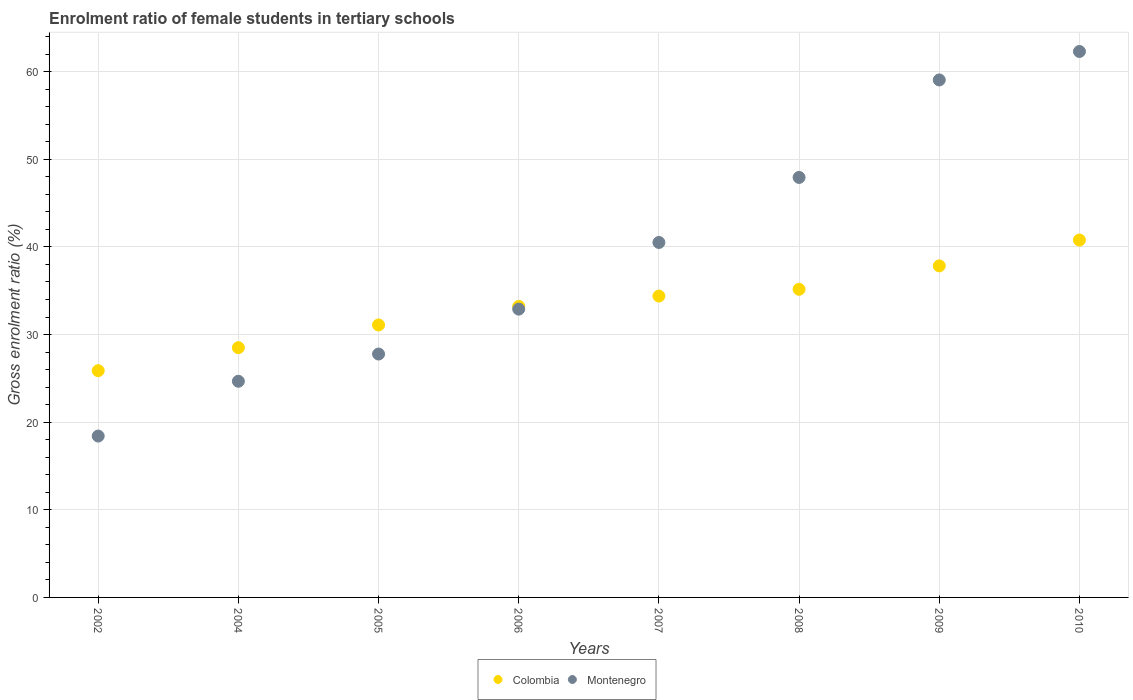How many different coloured dotlines are there?
Provide a short and direct response. 2. What is the enrolment ratio of female students in tertiary schools in Montenegro in 2010?
Offer a terse response. 62.31. Across all years, what is the maximum enrolment ratio of female students in tertiary schools in Colombia?
Keep it short and to the point. 40.79. Across all years, what is the minimum enrolment ratio of female students in tertiary schools in Colombia?
Your response must be concise. 25.88. What is the total enrolment ratio of female students in tertiary schools in Colombia in the graph?
Your answer should be very brief. 266.88. What is the difference between the enrolment ratio of female students in tertiary schools in Montenegro in 2006 and that in 2008?
Make the answer very short. -15.03. What is the difference between the enrolment ratio of female students in tertiary schools in Colombia in 2004 and the enrolment ratio of female students in tertiary schools in Montenegro in 2008?
Give a very brief answer. -19.43. What is the average enrolment ratio of female students in tertiary schools in Colombia per year?
Make the answer very short. 33.36. In the year 2005, what is the difference between the enrolment ratio of female students in tertiary schools in Montenegro and enrolment ratio of female students in tertiary schools in Colombia?
Give a very brief answer. -3.32. In how many years, is the enrolment ratio of female students in tertiary schools in Colombia greater than 32 %?
Offer a very short reply. 5. What is the ratio of the enrolment ratio of female students in tertiary schools in Colombia in 2006 to that in 2007?
Give a very brief answer. 0.97. Is the enrolment ratio of female students in tertiary schools in Montenegro in 2002 less than that in 2007?
Provide a succinct answer. Yes. What is the difference between the highest and the second highest enrolment ratio of female students in tertiary schools in Colombia?
Make the answer very short. 2.95. What is the difference between the highest and the lowest enrolment ratio of female students in tertiary schools in Colombia?
Your answer should be very brief. 14.91. Is the sum of the enrolment ratio of female students in tertiary schools in Montenegro in 2002 and 2005 greater than the maximum enrolment ratio of female students in tertiary schools in Colombia across all years?
Offer a very short reply. Yes. Is the enrolment ratio of female students in tertiary schools in Montenegro strictly greater than the enrolment ratio of female students in tertiary schools in Colombia over the years?
Provide a succinct answer. No. How many years are there in the graph?
Provide a short and direct response. 8. What is the difference between two consecutive major ticks on the Y-axis?
Keep it short and to the point. 10. Does the graph contain any zero values?
Give a very brief answer. No. How many legend labels are there?
Your answer should be compact. 2. How are the legend labels stacked?
Keep it short and to the point. Horizontal. What is the title of the graph?
Keep it short and to the point. Enrolment ratio of female students in tertiary schools. What is the Gross enrolment ratio (%) in Colombia in 2002?
Provide a succinct answer. 25.88. What is the Gross enrolment ratio (%) of Montenegro in 2002?
Make the answer very short. 18.42. What is the Gross enrolment ratio (%) in Colombia in 2004?
Offer a terse response. 28.51. What is the Gross enrolment ratio (%) of Montenegro in 2004?
Offer a very short reply. 24.67. What is the Gross enrolment ratio (%) in Colombia in 2005?
Offer a terse response. 31.1. What is the Gross enrolment ratio (%) in Montenegro in 2005?
Ensure brevity in your answer.  27.78. What is the Gross enrolment ratio (%) of Colombia in 2006?
Give a very brief answer. 33.22. What is the Gross enrolment ratio (%) in Montenegro in 2006?
Offer a terse response. 32.9. What is the Gross enrolment ratio (%) of Colombia in 2007?
Ensure brevity in your answer.  34.39. What is the Gross enrolment ratio (%) in Montenegro in 2007?
Provide a short and direct response. 40.51. What is the Gross enrolment ratio (%) in Colombia in 2008?
Make the answer very short. 35.17. What is the Gross enrolment ratio (%) in Montenegro in 2008?
Offer a very short reply. 47.93. What is the Gross enrolment ratio (%) in Colombia in 2009?
Give a very brief answer. 37.84. What is the Gross enrolment ratio (%) in Montenegro in 2009?
Your answer should be compact. 59.06. What is the Gross enrolment ratio (%) of Colombia in 2010?
Provide a short and direct response. 40.79. What is the Gross enrolment ratio (%) of Montenegro in 2010?
Your response must be concise. 62.31. Across all years, what is the maximum Gross enrolment ratio (%) in Colombia?
Offer a very short reply. 40.79. Across all years, what is the maximum Gross enrolment ratio (%) of Montenegro?
Provide a succinct answer. 62.31. Across all years, what is the minimum Gross enrolment ratio (%) in Colombia?
Keep it short and to the point. 25.88. Across all years, what is the minimum Gross enrolment ratio (%) of Montenegro?
Give a very brief answer. 18.42. What is the total Gross enrolment ratio (%) in Colombia in the graph?
Offer a very short reply. 266.88. What is the total Gross enrolment ratio (%) of Montenegro in the graph?
Provide a succinct answer. 313.58. What is the difference between the Gross enrolment ratio (%) in Colombia in 2002 and that in 2004?
Your answer should be compact. -2.63. What is the difference between the Gross enrolment ratio (%) of Montenegro in 2002 and that in 2004?
Your answer should be very brief. -6.25. What is the difference between the Gross enrolment ratio (%) in Colombia in 2002 and that in 2005?
Offer a very short reply. -5.22. What is the difference between the Gross enrolment ratio (%) of Montenegro in 2002 and that in 2005?
Provide a succinct answer. -9.36. What is the difference between the Gross enrolment ratio (%) of Colombia in 2002 and that in 2006?
Your response must be concise. -7.34. What is the difference between the Gross enrolment ratio (%) in Montenegro in 2002 and that in 2006?
Ensure brevity in your answer.  -14.49. What is the difference between the Gross enrolment ratio (%) of Colombia in 2002 and that in 2007?
Make the answer very short. -8.52. What is the difference between the Gross enrolment ratio (%) of Montenegro in 2002 and that in 2007?
Offer a terse response. -22.09. What is the difference between the Gross enrolment ratio (%) in Colombia in 2002 and that in 2008?
Provide a short and direct response. -9.29. What is the difference between the Gross enrolment ratio (%) in Montenegro in 2002 and that in 2008?
Make the answer very short. -29.52. What is the difference between the Gross enrolment ratio (%) in Colombia in 2002 and that in 2009?
Offer a terse response. -11.96. What is the difference between the Gross enrolment ratio (%) of Montenegro in 2002 and that in 2009?
Ensure brevity in your answer.  -40.64. What is the difference between the Gross enrolment ratio (%) of Colombia in 2002 and that in 2010?
Give a very brief answer. -14.91. What is the difference between the Gross enrolment ratio (%) of Montenegro in 2002 and that in 2010?
Offer a very short reply. -43.89. What is the difference between the Gross enrolment ratio (%) in Colombia in 2004 and that in 2005?
Provide a succinct answer. -2.59. What is the difference between the Gross enrolment ratio (%) of Montenegro in 2004 and that in 2005?
Make the answer very short. -3.11. What is the difference between the Gross enrolment ratio (%) of Colombia in 2004 and that in 2006?
Keep it short and to the point. -4.71. What is the difference between the Gross enrolment ratio (%) in Montenegro in 2004 and that in 2006?
Your answer should be very brief. -8.23. What is the difference between the Gross enrolment ratio (%) in Colombia in 2004 and that in 2007?
Offer a very short reply. -5.89. What is the difference between the Gross enrolment ratio (%) in Montenegro in 2004 and that in 2007?
Your answer should be very brief. -15.84. What is the difference between the Gross enrolment ratio (%) of Colombia in 2004 and that in 2008?
Your answer should be very brief. -6.66. What is the difference between the Gross enrolment ratio (%) of Montenegro in 2004 and that in 2008?
Make the answer very short. -23.26. What is the difference between the Gross enrolment ratio (%) of Colombia in 2004 and that in 2009?
Make the answer very short. -9.33. What is the difference between the Gross enrolment ratio (%) of Montenegro in 2004 and that in 2009?
Offer a very short reply. -34.39. What is the difference between the Gross enrolment ratio (%) of Colombia in 2004 and that in 2010?
Provide a short and direct response. -12.28. What is the difference between the Gross enrolment ratio (%) in Montenegro in 2004 and that in 2010?
Offer a very short reply. -37.64. What is the difference between the Gross enrolment ratio (%) of Colombia in 2005 and that in 2006?
Provide a short and direct response. -2.12. What is the difference between the Gross enrolment ratio (%) in Montenegro in 2005 and that in 2006?
Your answer should be compact. -5.12. What is the difference between the Gross enrolment ratio (%) in Colombia in 2005 and that in 2007?
Make the answer very short. -3.3. What is the difference between the Gross enrolment ratio (%) of Montenegro in 2005 and that in 2007?
Your answer should be compact. -12.73. What is the difference between the Gross enrolment ratio (%) of Colombia in 2005 and that in 2008?
Provide a short and direct response. -4.07. What is the difference between the Gross enrolment ratio (%) of Montenegro in 2005 and that in 2008?
Ensure brevity in your answer.  -20.16. What is the difference between the Gross enrolment ratio (%) in Colombia in 2005 and that in 2009?
Your answer should be very brief. -6.74. What is the difference between the Gross enrolment ratio (%) of Montenegro in 2005 and that in 2009?
Give a very brief answer. -31.28. What is the difference between the Gross enrolment ratio (%) of Colombia in 2005 and that in 2010?
Your answer should be very brief. -9.69. What is the difference between the Gross enrolment ratio (%) of Montenegro in 2005 and that in 2010?
Ensure brevity in your answer.  -34.53. What is the difference between the Gross enrolment ratio (%) in Colombia in 2006 and that in 2007?
Make the answer very short. -1.18. What is the difference between the Gross enrolment ratio (%) of Montenegro in 2006 and that in 2007?
Provide a succinct answer. -7.61. What is the difference between the Gross enrolment ratio (%) of Colombia in 2006 and that in 2008?
Make the answer very short. -1.95. What is the difference between the Gross enrolment ratio (%) of Montenegro in 2006 and that in 2008?
Offer a terse response. -15.03. What is the difference between the Gross enrolment ratio (%) in Colombia in 2006 and that in 2009?
Provide a succinct answer. -4.62. What is the difference between the Gross enrolment ratio (%) in Montenegro in 2006 and that in 2009?
Ensure brevity in your answer.  -26.16. What is the difference between the Gross enrolment ratio (%) in Colombia in 2006 and that in 2010?
Give a very brief answer. -7.57. What is the difference between the Gross enrolment ratio (%) in Montenegro in 2006 and that in 2010?
Ensure brevity in your answer.  -29.4. What is the difference between the Gross enrolment ratio (%) in Colombia in 2007 and that in 2008?
Ensure brevity in your answer.  -0.77. What is the difference between the Gross enrolment ratio (%) of Montenegro in 2007 and that in 2008?
Provide a short and direct response. -7.42. What is the difference between the Gross enrolment ratio (%) of Colombia in 2007 and that in 2009?
Provide a succinct answer. -3.45. What is the difference between the Gross enrolment ratio (%) in Montenegro in 2007 and that in 2009?
Ensure brevity in your answer.  -18.55. What is the difference between the Gross enrolment ratio (%) in Colombia in 2007 and that in 2010?
Provide a short and direct response. -6.4. What is the difference between the Gross enrolment ratio (%) in Montenegro in 2007 and that in 2010?
Give a very brief answer. -21.8. What is the difference between the Gross enrolment ratio (%) in Colombia in 2008 and that in 2009?
Provide a short and direct response. -2.67. What is the difference between the Gross enrolment ratio (%) of Montenegro in 2008 and that in 2009?
Make the answer very short. -11.13. What is the difference between the Gross enrolment ratio (%) in Colombia in 2008 and that in 2010?
Give a very brief answer. -5.62. What is the difference between the Gross enrolment ratio (%) of Montenegro in 2008 and that in 2010?
Offer a terse response. -14.37. What is the difference between the Gross enrolment ratio (%) of Colombia in 2009 and that in 2010?
Your response must be concise. -2.95. What is the difference between the Gross enrolment ratio (%) of Montenegro in 2009 and that in 2010?
Your response must be concise. -3.25. What is the difference between the Gross enrolment ratio (%) of Colombia in 2002 and the Gross enrolment ratio (%) of Montenegro in 2004?
Provide a succinct answer. 1.21. What is the difference between the Gross enrolment ratio (%) in Colombia in 2002 and the Gross enrolment ratio (%) in Montenegro in 2005?
Give a very brief answer. -1.9. What is the difference between the Gross enrolment ratio (%) of Colombia in 2002 and the Gross enrolment ratio (%) of Montenegro in 2006?
Your answer should be compact. -7.02. What is the difference between the Gross enrolment ratio (%) of Colombia in 2002 and the Gross enrolment ratio (%) of Montenegro in 2007?
Your response must be concise. -14.63. What is the difference between the Gross enrolment ratio (%) in Colombia in 2002 and the Gross enrolment ratio (%) in Montenegro in 2008?
Your answer should be compact. -22.06. What is the difference between the Gross enrolment ratio (%) in Colombia in 2002 and the Gross enrolment ratio (%) in Montenegro in 2009?
Your response must be concise. -33.18. What is the difference between the Gross enrolment ratio (%) in Colombia in 2002 and the Gross enrolment ratio (%) in Montenegro in 2010?
Provide a short and direct response. -36.43. What is the difference between the Gross enrolment ratio (%) of Colombia in 2004 and the Gross enrolment ratio (%) of Montenegro in 2005?
Your answer should be very brief. 0.73. What is the difference between the Gross enrolment ratio (%) of Colombia in 2004 and the Gross enrolment ratio (%) of Montenegro in 2006?
Keep it short and to the point. -4.4. What is the difference between the Gross enrolment ratio (%) in Colombia in 2004 and the Gross enrolment ratio (%) in Montenegro in 2007?
Make the answer very short. -12. What is the difference between the Gross enrolment ratio (%) in Colombia in 2004 and the Gross enrolment ratio (%) in Montenegro in 2008?
Ensure brevity in your answer.  -19.43. What is the difference between the Gross enrolment ratio (%) in Colombia in 2004 and the Gross enrolment ratio (%) in Montenegro in 2009?
Provide a short and direct response. -30.55. What is the difference between the Gross enrolment ratio (%) of Colombia in 2004 and the Gross enrolment ratio (%) of Montenegro in 2010?
Your answer should be very brief. -33.8. What is the difference between the Gross enrolment ratio (%) in Colombia in 2005 and the Gross enrolment ratio (%) in Montenegro in 2006?
Provide a succinct answer. -1.81. What is the difference between the Gross enrolment ratio (%) of Colombia in 2005 and the Gross enrolment ratio (%) of Montenegro in 2007?
Make the answer very short. -9.41. What is the difference between the Gross enrolment ratio (%) in Colombia in 2005 and the Gross enrolment ratio (%) in Montenegro in 2008?
Make the answer very short. -16.84. What is the difference between the Gross enrolment ratio (%) in Colombia in 2005 and the Gross enrolment ratio (%) in Montenegro in 2009?
Provide a succinct answer. -27.96. What is the difference between the Gross enrolment ratio (%) of Colombia in 2005 and the Gross enrolment ratio (%) of Montenegro in 2010?
Make the answer very short. -31.21. What is the difference between the Gross enrolment ratio (%) in Colombia in 2006 and the Gross enrolment ratio (%) in Montenegro in 2007?
Offer a terse response. -7.29. What is the difference between the Gross enrolment ratio (%) in Colombia in 2006 and the Gross enrolment ratio (%) in Montenegro in 2008?
Give a very brief answer. -14.72. What is the difference between the Gross enrolment ratio (%) of Colombia in 2006 and the Gross enrolment ratio (%) of Montenegro in 2009?
Ensure brevity in your answer.  -25.84. What is the difference between the Gross enrolment ratio (%) of Colombia in 2006 and the Gross enrolment ratio (%) of Montenegro in 2010?
Offer a very short reply. -29.09. What is the difference between the Gross enrolment ratio (%) of Colombia in 2007 and the Gross enrolment ratio (%) of Montenegro in 2008?
Your response must be concise. -13.54. What is the difference between the Gross enrolment ratio (%) in Colombia in 2007 and the Gross enrolment ratio (%) in Montenegro in 2009?
Your response must be concise. -24.67. What is the difference between the Gross enrolment ratio (%) in Colombia in 2007 and the Gross enrolment ratio (%) in Montenegro in 2010?
Keep it short and to the point. -27.91. What is the difference between the Gross enrolment ratio (%) in Colombia in 2008 and the Gross enrolment ratio (%) in Montenegro in 2009?
Offer a terse response. -23.89. What is the difference between the Gross enrolment ratio (%) in Colombia in 2008 and the Gross enrolment ratio (%) in Montenegro in 2010?
Provide a succinct answer. -27.14. What is the difference between the Gross enrolment ratio (%) in Colombia in 2009 and the Gross enrolment ratio (%) in Montenegro in 2010?
Provide a short and direct response. -24.47. What is the average Gross enrolment ratio (%) in Colombia per year?
Your answer should be very brief. 33.36. What is the average Gross enrolment ratio (%) of Montenegro per year?
Make the answer very short. 39.2. In the year 2002, what is the difference between the Gross enrolment ratio (%) of Colombia and Gross enrolment ratio (%) of Montenegro?
Your answer should be very brief. 7.46. In the year 2004, what is the difference between the Gross enrolment ratio (%) of Colombia and Gross enrolment ratio (%) of Montenegro?
Your answer should be very brief. 3.84. In the year 2005, what is the difference between the Gross enrolment ratio (%) in Colombia and Gross enrolment ratio (%) in Montenegro?
Your answer should be very brief. 3.32. In the year 2006, what is the difference between the Gross enrolment ratio (%) in Colombia and Gross enrolment ratio (%) in Montenegro?
Give a very brief answer. 0.31. In the year 2007, what is the difference between the Gross enrolment ratio (%) in Colombia and Gross enrolment ratio (%) in Montenegro?
Your answer should be very brief. -6.12. In the year 2008, what is the difference between the Gross enrolment ratio (%) in Colombia and Gross enrolment ratio (%) in Montenegro?
Your answer should be very brief. -12.77. In the year 2009, what is the difference between the Gross enrolment ratio (%) in Colombia and Gross enrolment ratio (%) in Montenegro?
Your answer should be very brief. -21.22. In the year 2010, what is the difference between the Gross enrolment ratio (%) of Colombia and Gross enrolment ratio (%) of Montenegro?
Ensure brevity in your answer.  -21.52. What is the ratio of the Gross enrolment ratio (%) in Colombia in 2002 to that in 2004?
Offer a very short reply. 0.91. What is the ratio of the Gross enrolment ratio (%) in Montenegro in 2002 to that in 2004?
Ensure brevity in your answer.  0.75. What is the ratio of the Gross enrolment ratio (%) in Colombia in 2002 to that in 2005?
Your answer should be very brief. 0.83. What is the ratio of the Gross enrolment ratio (%) of Montenegro in 2002 to that in 2005?
Ensure brevity in your answer.  0.66. What is the ratio of the Gross enrolment ratio (%) of Colombia in 2002 to that in 2006?
Offer a terse response. 0.78. What is the ratio of the Gross enrolment ratio (%) of Montenegro in 2002 to that in 2006?
Provide a short and direct response. 0.56. What is the ratio of the Gross enrolment ratio (%) of Colombia in 2002 to that in 2007?
Provide a short and direct response. 0.75. What is the ratio of the Gross enrolment ratio (%) of Montenegro in 2002 to that in 2007?
Give a very brief answer. 0.45. What is the ratio of the Gross enrolment ratio (%) of Colombia in 2002 to that in 2008?
Offer a terse response. 0.74. What is the ratio of the Gross enrolment ratio (%) of Montenegro in 2002 to that in 2008?
Give a very brief answer. 0.38. What is the ratio of the Gross enrolment ratio (%) of Colombia in 2002 to that in 2009?
Provide a succinct answer. 0.68. What is the ratio of the Gross enrolment ratio (%) in Montenegro in 2002 to that in 2009?
Ensure brevity in your answer.  0.31. What is the ratio of the Gross enrolment ratio (%) in Colombia in 2002 to that in 2010?
Offer a terse response. 0.63. What is the ratio of the Gross enrolment ratio (%) of Montenegro in 2002 to that in 2010?
Provide a succinct answer. 0.3. What is the ratio of the Gross enrolment ratio (%) of Colombia in 2004 to that in 2005?
Keep it short and to the point. 0.92. What is the ratio of the Gross enrolment ratio (%) in Montenegro in 2004 to that in 2005?
Give a very brief answer. 0.89. What is the ratio of the Gross enrolment ratio (%) of Colombia in 2004 to that in 2006?
Provide a succinct answer. 0.86. What is the ratio of the Gross enrolment ratio (%) of Montenegro in 2004 to that in 2006?
Your answer should be very brief. 0.75. What is the ratio of the Gross enrolment ratio (%) in Colombia in 2004 to that in 2007?
Keep it short and to the point. 0.83. What is the ratio of the Gross enrolment ratio (%) in Montenegro in 2004 to that in 2007?
Offer a very short reply. 0.61. What is the ratio of the Gross enrolment ratio (%) of Colombia in 2004 to that in 2008?
Offer a terse response. 0.81. What is the ratio of the Gross enrolment ratio (%) of Montenegro in 2004 to that in 2008?
Your answer should be compact. 0.51. What is the ratio of the Gross enrolment ratio (%) in Colombia in 2004 to that in 2009?
Ensure brevity in your answer.  0.75. What is the ratio of the Gross enrolment ratio (%) of Montenegro in 2004 to that in 2009?
Your answer should be compact. 0.42. What is the ratio of the Gross enrolment ratio (%) of Colombia in 2004 to that in 2010?
Provide a short and direct response. 0.7. What is the ratio of the Gross enrolment ratio (%) of Montenegro in 2004 to that in 2010?
Keep it short and to the point. 0.4. What is the ratio of the Gross enrolment ratio (%) of Colombia in 2005 to that in 2006?
Your answer should be compact. 0.94. What is the ratio of the Gross enrolment ratio (%) in Montenegro in 2005 to that in 2006?
Give a very brief answer. 0.84. What is the ratio of the Gross enrolment ratio (%) in Colombia in 2005 to that in 2007?
Ensure brevity in your answer.  0.9. What is the ratio of the Gross enrolment ratio (%) of Montenegro in 2005 to that in 2007?
Your response must be concise. 0.69. What is the ratio of the Gross enrolment ratio (%) in Colombia in 2005 to that in 2008?
Your response must be concise. 0.88. What is the ratio of the Gross enrolment ratio (%) of Montenegro in 2005 to that in 2008?
Keep it short and to the point. 0.58. What is the ratio of the Gross enrolment ratio (%) in Colombia in 2005 to that in 2009?
Provide a succinct answer. 0.82. What is the ratio of the Gross enrolment ratio (%) of Montenegro in 2005 to that in 2009?
Your response must be concise. 0.47. What is the ratio of the Gross enrolment ratio (%) in Colombia in 2005 to that in 2010?
Your answer should be compact. 0.76. What is the ratio of the Gross enrolment ratio (%) of Montenegro in 2005 to that in 2010?
Offer a very short reply. 0.45. What is the ratio of the Gross enrolment ratio (%) in Colombia in 2006 to that in 2007?
Give a very brief answer. 0.97. What is the ratio of the Gross enrolment ratio (%) of Montenegro in 2006 to that in 2007?
Provide a succinct answer. 0.81. What is the ratio of the Gross enrolment ratio (%) in Colombia in 2006 to that in 2008?
Your response must be concise. 0.94. What is the ratio of the Gross enrolment ratio (%) of Montenegro in 2006 to that in 2008?
Ensure brevity in your answer.  0.69. What is the ratio of the Gross enrolment ratio (%) in Colombia in 2006 to that in 2009?
Make the answer very short. 0.88. What is the ratio of the Gross enrolment ratio (%) of Montenegro in 2006 to that in 2009?
Ensure brevity in your answer.  0.56. What is the ratio of the Gross enrolment ratio (%) of Colombia in 2006 to that in 2010?
Give a very brief answer. 0.81. What is the ratio of the Gross enrolment ratio (%) in Montenegro in 2006 to that in 2010?
Your response must be concise. 0.53. What is the ratio of the Gross enrolment ratio (%) in Colombia in 2007 to that in 2008?
Offer a terse response. 0.98. What is the ratio of the Gross enrolment ratio (%) in Montenegro in 2007 to that in 2008?
Your answer should be very brief. 0.85. What is the ratio of the Gross enrolment ratio (%) in Colombia in 2007 to that in 2009?
Offer a terse response. 0.91. What is the ratio of the Gross enrolment ratio (%) in Montenegro in 2007 to that in 2009?
Give a very brief answer. 0.69. What is the ratio of the Gross enrolment ratio (%) of Colombia in 2007 to that in 2010?
Your answer should be compact. 0.84. What is the ratio of the Gross enrolment ratio (%) of Montenegro in 2007 to that in 2010?
Offer a very short reply. 0.65. What is the ratio of the Gross enrolment ratio (%) in Colombia in 2008 to that in 2009?
Keep it short and to the point. 0.93. What is the ratio of the Gross enrolment ratio (%) in Montenegro in 2008 to that in 2009?
Make the answer very short. 0.81. What is the ratio of the Gross enrolment ratio (%) in Colombia in 2008 to that in 2010?
Make the answer very short. 0.86. What is the ratio of the Gross enrolment ratio (%) in Montenegro in 2008 to that in 2010?
Offer a terse response. 0.77. What is the ratio of the Gross enrolment ratio (%) of Colombia in 2009 to that in 2010?
Ensure brevity in your answer.  0.93. What is the ratio of the Gross enrolment ratio (%) of Montenegro in 2009 to that in 2010?
Provide a short and direct response. 0.95. What is the difference between the highest and the second highest Gross enrolment ratio (%) of Colombia?
Provide a succinct answer. 2.95. What is the difference between the highest and the second highest Gross enrolment ratio (%) in Montenegro?
Give a very brief answer. 3.25. What is the difference between the highest and the lowest Gross enrolment ratio (%) of Colombia?
Keep it short and to the point. 14.91. What is the difference between the highest and the lowest Gross enrolment ratio (%) in Montenegro?
Offer a very short reply. 43.89. 